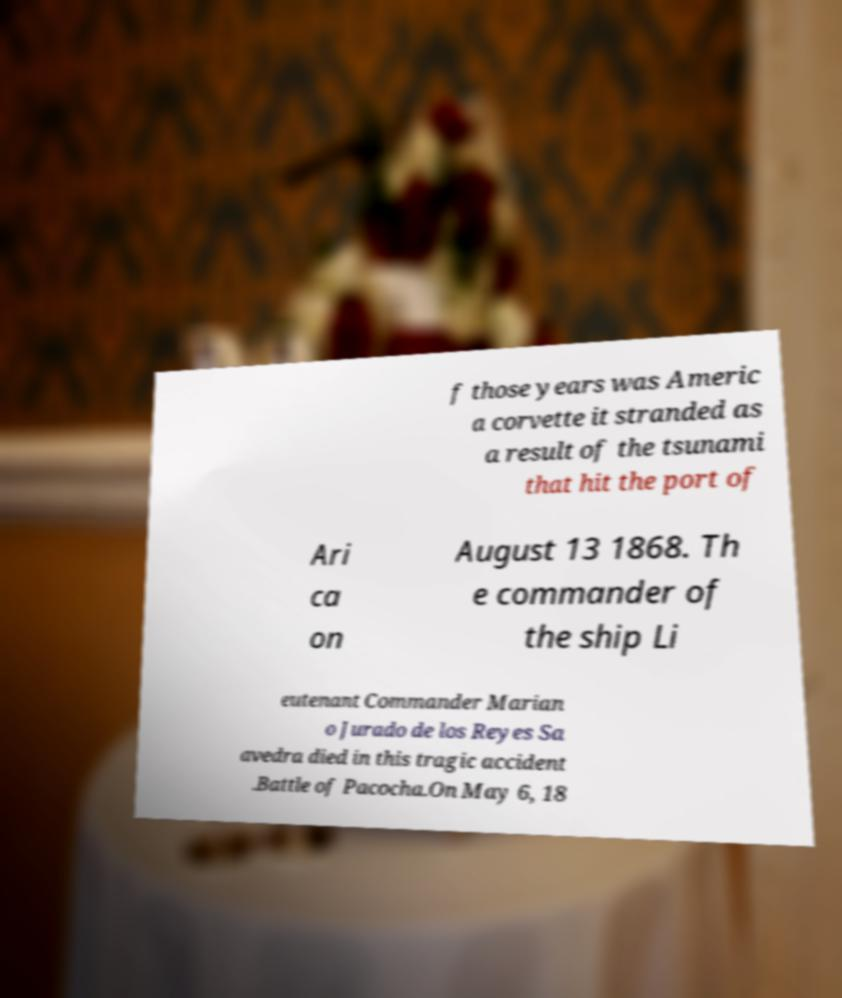What messages or text are displayed in this image? I need them in a readable, typed format. f those years was Americ a corvette it stranded as a result of the tsunami that hit the port of Ari ca on August 13 1868. Th e commander of the ship Li eutenant Commander Marian o Jurado de los Reyes Sa avedra died in this tragic accident .Battle of Pacocha.On May 6, 18 